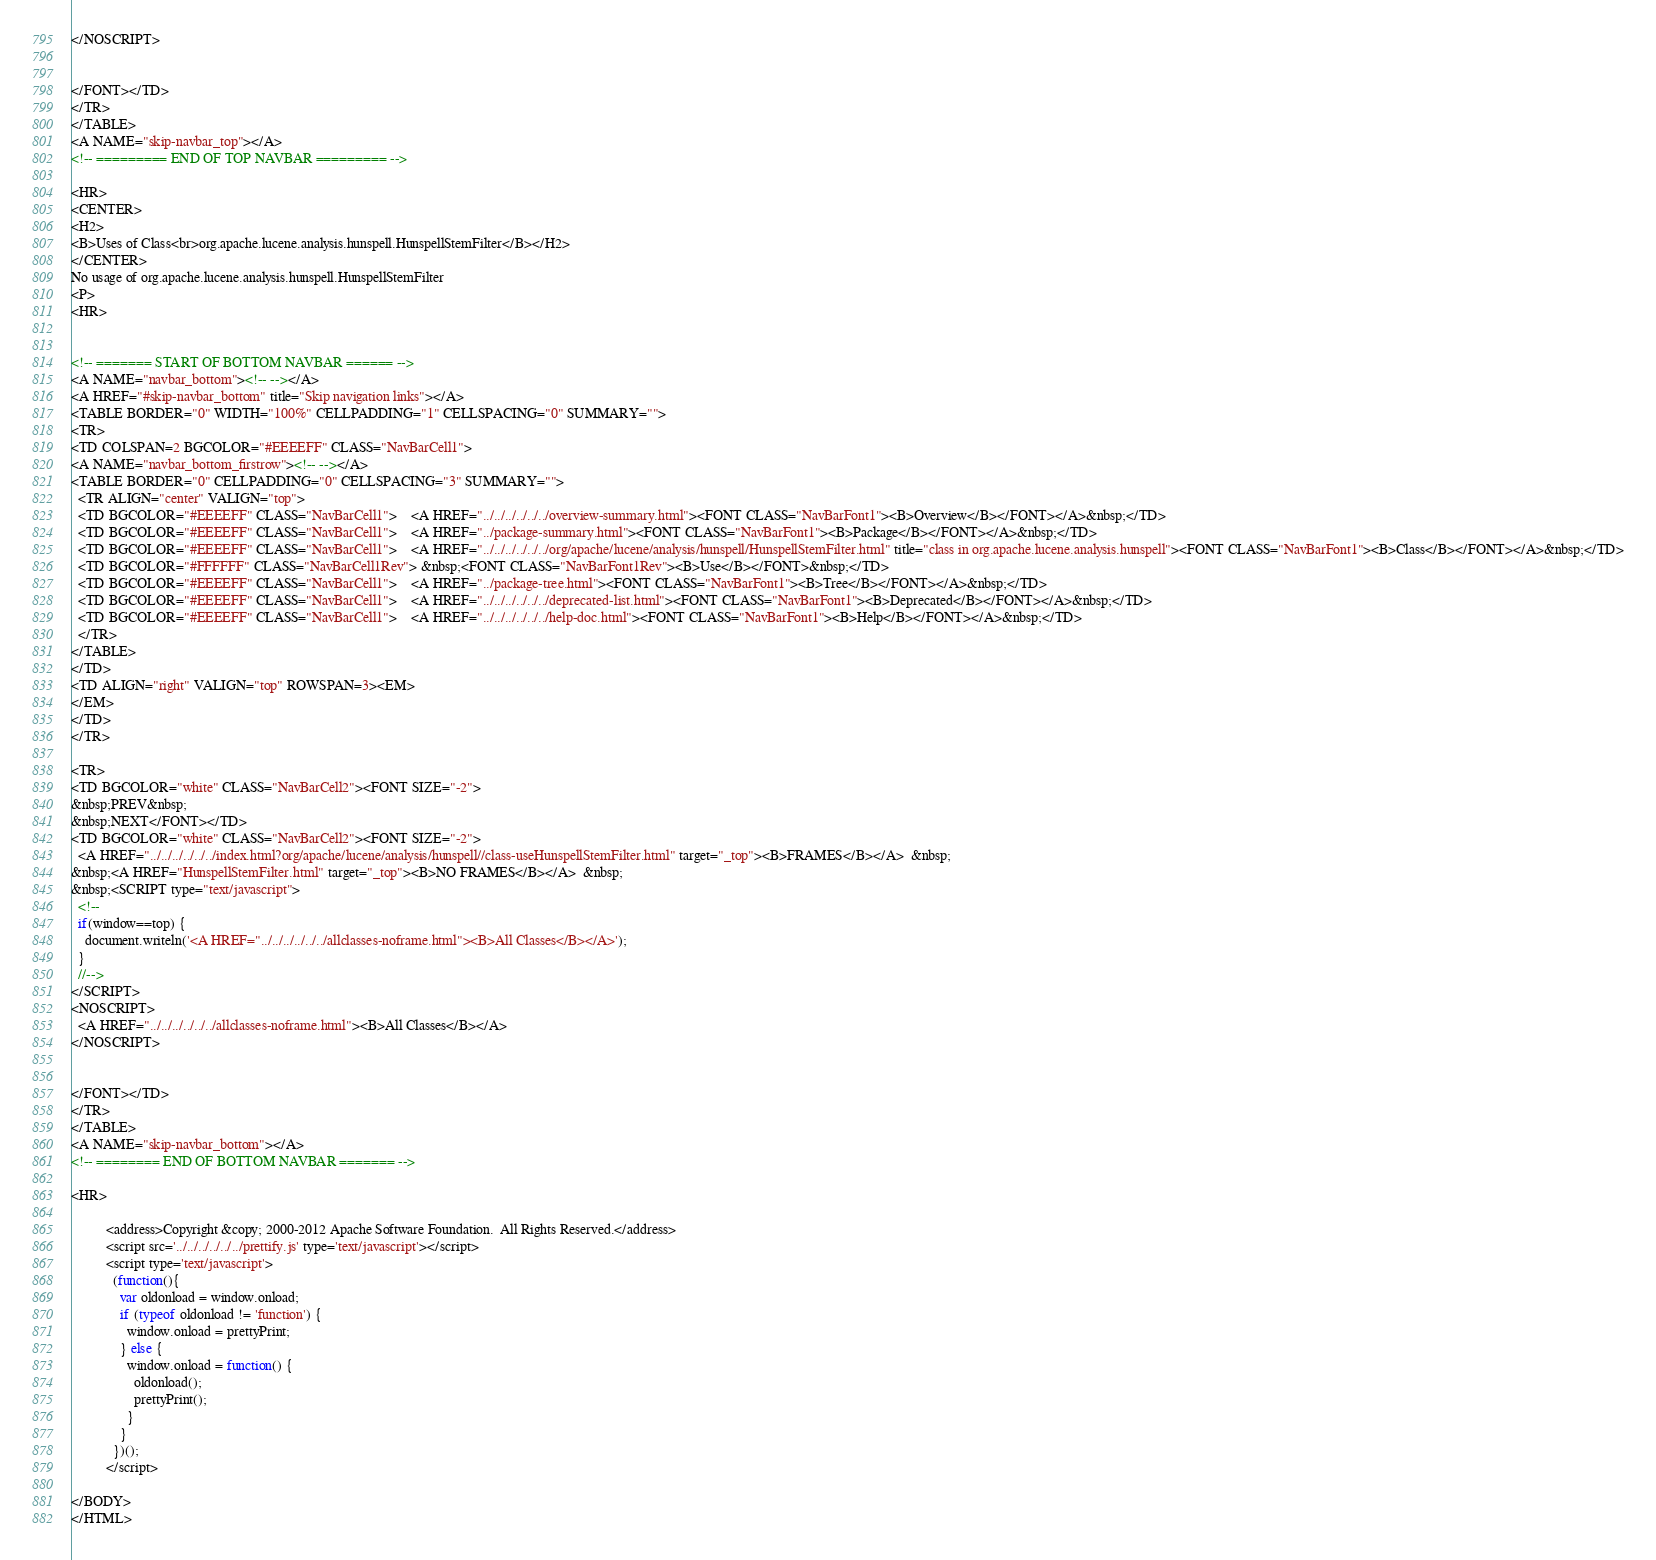<code> <loc_0><loc_0><loc_500><loc_500><_HTML_></NOSCRIPT>


</FONT></TD>
</TR>
</TABLE>
<A NAME="skip-navbar_top"></A>
<!-- ========= END OF TOP NAVBAR ========= -->

<HR>
<CENTER>
<H2>
<B>Uses of Class<br>org.apache.lucene.analysis.hunspell.HunspellStemFilter</B></H2>
</CENTER>
No usage of org.apache.lucene.analysis.hunspell.HunspellStemFilter
<P>
<HR>


<!-- ======= START OF BOTTOM NAVBAR ====== -->
<A NAME="navbar_bottom"><!-- --></A>
<A HREF="#skip-navbar_bottom" title="Skip navigation links"></A>
<TABLE BORDER="0" WIDTH="100%" CELLPADDING="1" CELLSPACING="0" SUMMARY="">
<TR>
<TD COLSPAN=2 BGCOLOR="#EEEEFF" CLASS="NavBarCell1">
<A NAME="navbar_bottom_firstrow"><!-- --></A>
<TABLE BORDER="0" CELLPADDING="0" CELLSPACING="3" SUMMARY="">
  <TR ALIGN="center" VALIGN="top">
  <TD BGCOLOR="#EEEEFF" CLASS="NavBarCell1">    <A HREF="../../../../../../overview-summary.html"><FONT CLASS="NavBarFont1"><B>Overview</B></FONT></A>&nbsp;</TD>
  <TD BGCOLOR="#EEEEFF" CLASS="NavBarCell1">    <A HREF="../package-summary.html"><FONT CLASS="NavBarFont1"><B>Package</B></FONT></A>&nbsp;</TD>
  <TD BGCOLOR="#EEEEFF" CLASS="NavBarCell1">    <A HREF="../../../../../../org/apache/lucene/analysis/hunspell/HunspellStemFilter.html" title="class in org.apache.lucene.analysis.hunspell"><FONT CLASS="NavBarFont1"><B>Class</B></FONT></A>&nbsp;</TD>
  <TD BGCOLOR="#FFFFFF" CLASS="NavBarCell1Rev"> &nbsp;<FONT CLASS="NavBarFont1Rev"><B>Use</B></FONT>&nbsp;</TD>
  <TD BGCOLOR="#EEEEFF" CLASS="NavBarCell1">    <A HREF="../package-tree.html"><FONT CLASS="NavBarFont1"><B>Tree</B></FONT></A>&nbsp;</TD>
  <TD BGCOLOR="#EEEEFF" CLASS="NavBarCell1">    <A HREF="../../../../../../deprecated-list.html"><FONT CLASS="NavBarFont1"><B>Deprecated</B></FONT></A>&nbsp;</TD>
  <TD BGCOLOR="#EEEEFF" CLASS="NavBarCell1">    <A HREF="../../../../../../help-doc.html"><FONT CLASS="NavBarFont1"><B>Help</B></FONT></A>&nbsp;</TD>
  </TR>
</TABLE>
</TD>
<TD ALIGN="right" VALIGN="top" ROWSPAN=3><EM>
</EM>
</TD>
</TR>

<TR>
<TD BGCOLOR="white" CLASS="NavBarCell2"><FONT SIZE="-2">
&nbsp;PREV&nbsp;
&nbsp;NEXT</FONT></TD>
<TD BGCOLOR="white" CLASS="NavBarCell2"><FONT SIZE="-2">
  <A HREF="../../../../../../index.html?org/apache/lucene/analysis/hunspell//class-useHunspellStemFilter.html" target="_top"><B>FRAMES</B></A>  &nbsp;
&nbsp;<A HREF="HunspellStemFilter.html" target="_top"><B>NO FRAMES</B></A>  &nbsp;
&nbsp;<SCRIPT type="text/javascript">
  <!--
  if(window==top) {
    document.writeln('<A HREF="../../../../../../allclasses-noframe.html"><B>All Classes</B></A>');
  }
  //-->
</SCRIPT>
<NOSCRIPT>
  <A HREF="../../../../../../allclasses-noframe.html"><B>All Classes</B></A>
</NOSCRIPT>


</FONT></TD>
</TR>
</TABLE>
<A NAME="skip-navbar_bottom"></A>
<!-- ======== END OF BOTTOM NAVBAR ======= -->

<HR>

          <address>Copyright &copy; 2000-2012 Apache Software Foundation.  All Rights Reserved.</address>
          <script src='../../../../../../prettify.js' type='text/javascript'></script>
          <script type='text/javascript'>
            (function(){
              var oldonload = window.onload;
              if (typeof oldonload != 'function') {
                window.onload = prettyPrint;
              } else {
                window.onload = function() {
                  oldonload();
                  prettyPrint();
                }
              }
            })();
          </script>
        
</BODY>
</HTML>
</code> 